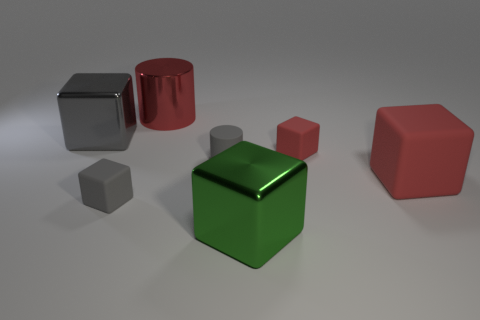There is a green metallic thing that is the same size as the metal cylinder; what is its shape? The green metallic object you're inquiring about is a cube, a solid three-dimensional figure with six square faces, all of which are equal in size. 